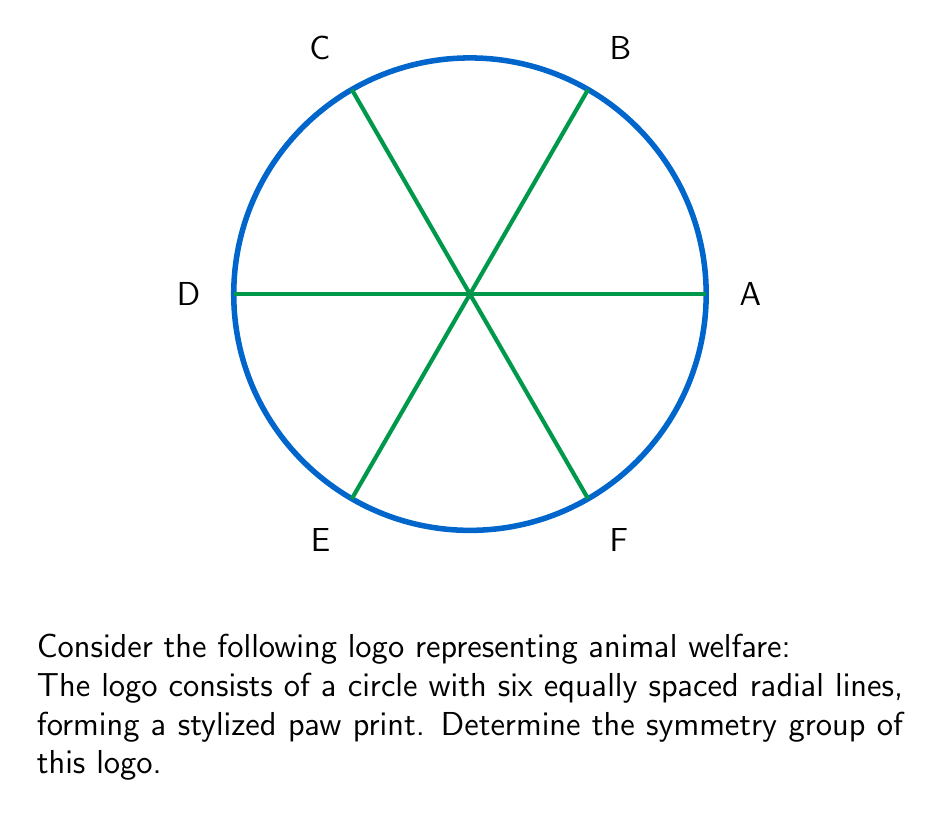Show me your answer to this math problem. To determine the symmetry group of the logo, we need to identify all the symmetry operations that leave the logo unchanged. Let's analyze this step-by-step:

1. Rotational symmetries:
   - The logo remains unchanged when rotated by multiples of 60° (or $\frac{\pi}{3}$ radians) around its center.
   - There are 6 distinct rotations: 0°, 60°, 120°, 180°, 240°, and 300°.

2. Reflection symmetries:
   - The logo has 6 lines of reflection, coinciding with the 6 radial lines.

3. Identity transformation:
   - The identity transformation (no change) is always a symmetry.

These symmetries form a group under composition. This group is isomorphic to the dihedral group $D_6$, which has order 12.

The elements of $D_6$ can be represented as:
- 6 rotations: $r^0, r^1, r^2, r^3, r^4, r^5$ (where $r$ represents a 60° rotation)
- 6 reflections: $s_1, s_2, s_3, s_4, s_5, s_6$ (corresponding to the 6 lines of reflection)

The group operation table for $D_6$ would show how these elements combine under composition.

In the context of communicating regulations, this symmetry group analysis could be used to ensure that any modifications or variations of the logo maintain its essential symmetry properties, preserving its recognizability and symbolic meaning in animal welfare campaigns.
Answer: $D_6$ 